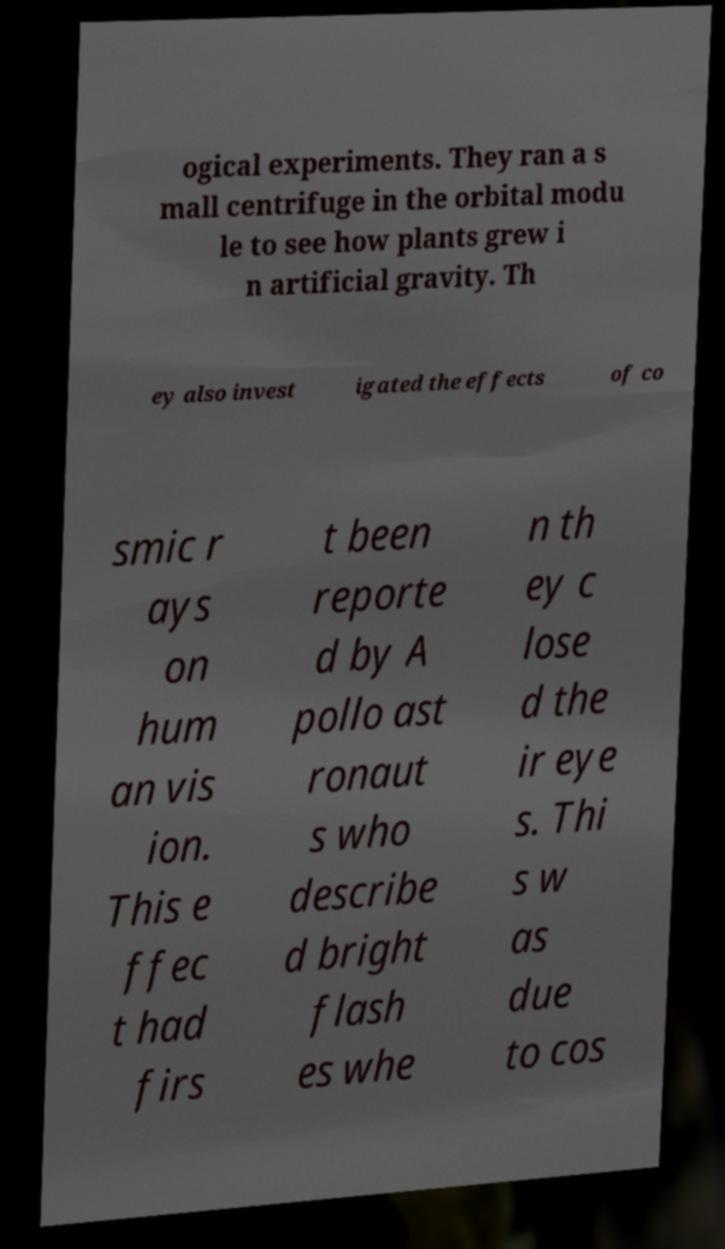Could you assist in decoding the text presented in this image and type it out clearly? ogical experiments. They ran a s mall centrifuge in the orbital modu le to see how plants grew i n artificial gravity. Th ey also invest igated the effects of co smic r ays on hum an vis ion. This e ffec t had firs t been reporte d by A pollo ast ronaut s who describe d bright flash es whe n th ey c lose d the ir eye s. Thi s w as due to cos 